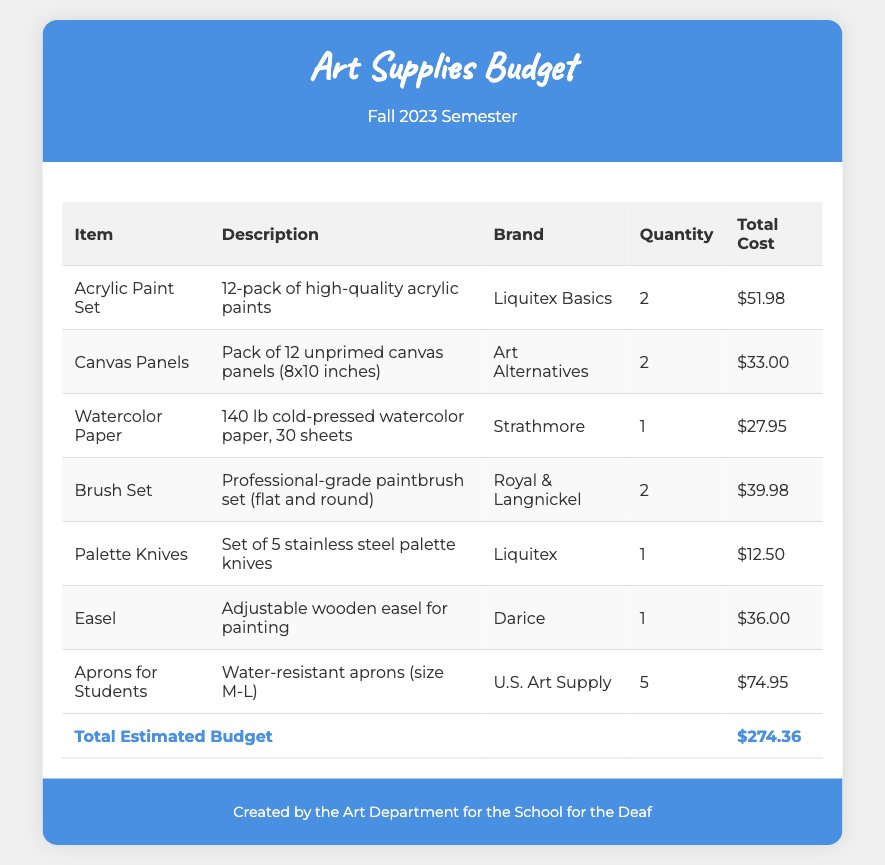What is the total estimated budget? The total estimated budget is provided in the footer of the document.
Answer: $274.36 How many Acrylic Paint Sets are needed? The quantity of Acrylic Paint Sets is listed in the document's table.
Answer: 2 What brand is the Watercolor Paper? The brand of the Watercolor Paper is specified in the document.
Answer: Strathmore What is the total cost of Canvas Panels? The total cost is listed in the corresponding row of the table.
Answer: $33.00 How many brushes are included in the Brush Set? The Brush Set description mentions the type of brushes included.
Answer: Professional-grade What is the total quantity of Aprons for Students? The quantity of Aprons for Students is indicated in the table.
Answer: 5 What type of easel is included in the budget? The description in the document explains the type of easel.
Answer: Adjustable wooden easel Which brand offers the Palette Knives? The brand for the Palette Knives is stated in the document.
Answer: Liquitex How many sheets of Watercolor Paper are included? The description of Watercolor Paper specifies the number of sheets.
Answer: 30 sheets 